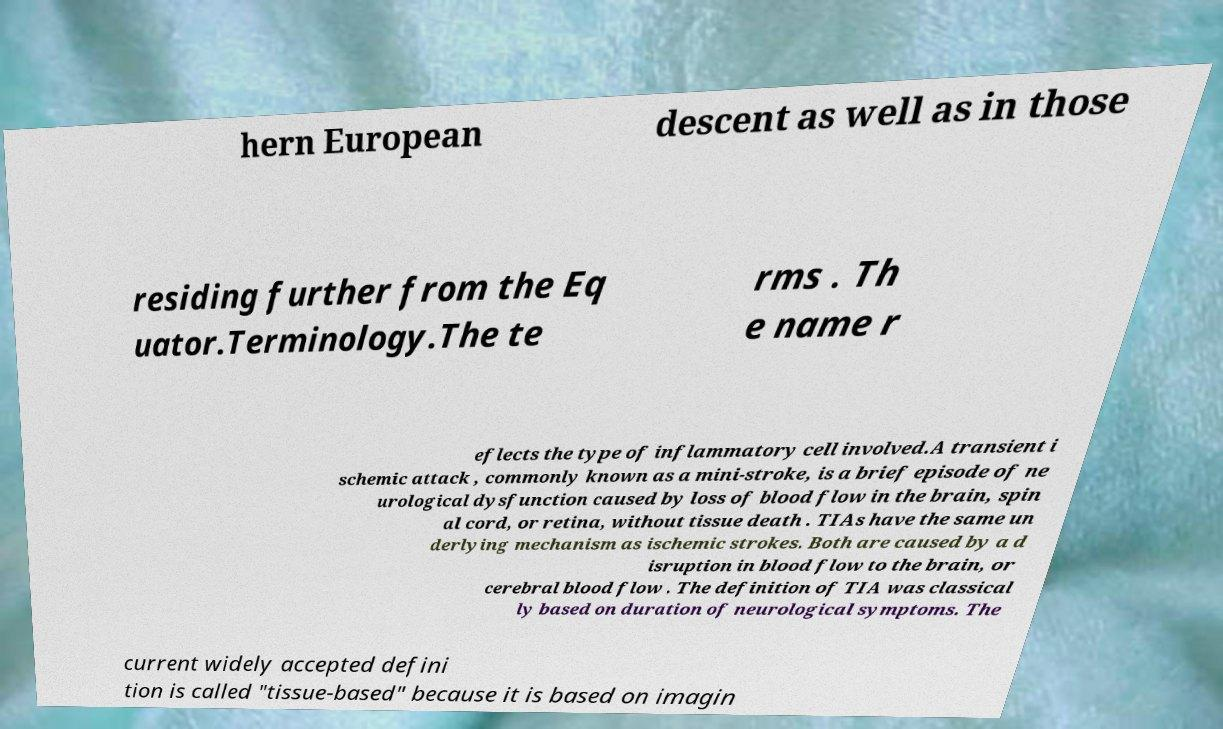There's text embedded in this image that I need extracted. Can you transcribe it verbatim? hern European descent as well as in those residing further from the Eq uator.Terminology.The te rms . Th e name r eflects the type of inflammatory cell involved.A transient i schemic attack , commonly known as a mini-stroke, is a brief episode of ne urological dysfunction caused by loss of blood flow in the brain, spin al cord, or retina, without tissue death . TIAs have the same un derlying mechanism as ischemic strokes. Both are caused by a d isruption in blood flow to the brain, or cerebral blood flow . The definition of TIA was classical ly based on duration of neurological symptoms. The current widely accepted defini tion is called "tissue-based" because it is based on imagin 